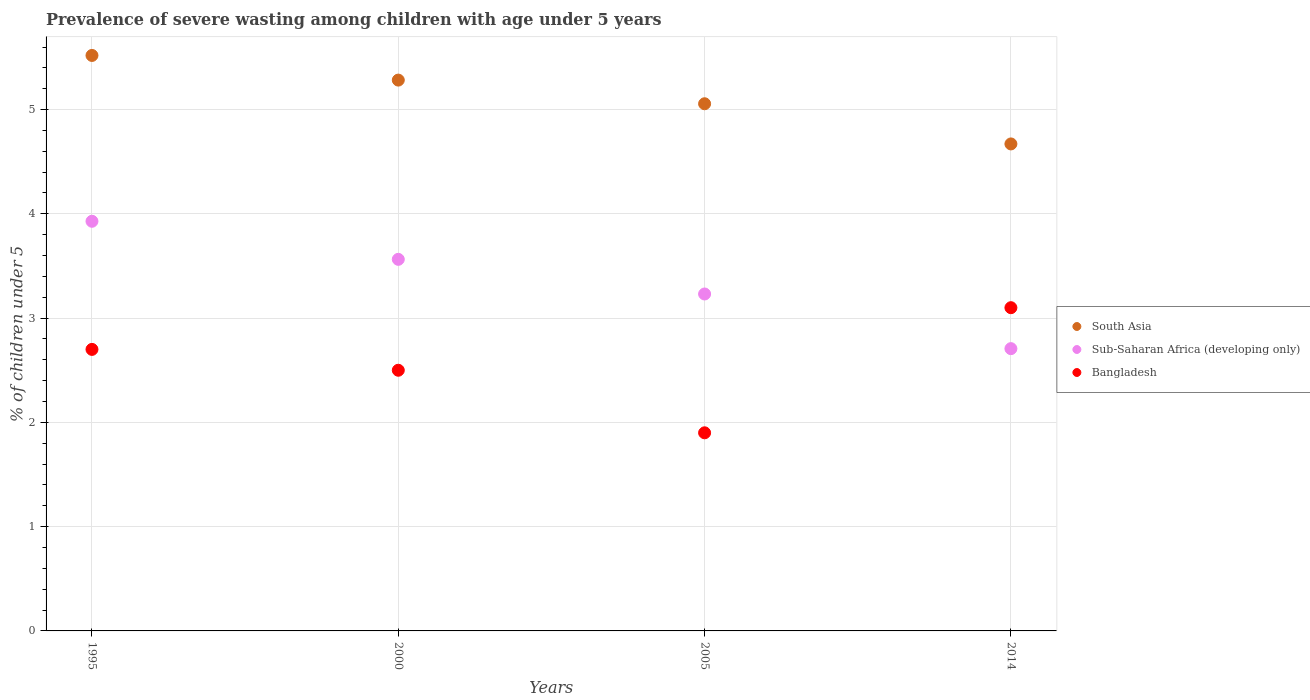Is the number of dotlines equal to the number of legend labels?
Provide a short and direct response. Yes. Across all years, what is the maximum percentage of severely wasted children in South Asia?
Provide a succinct answer. 5.52. Across all years, what is the minimum percentage of severely wasted children in Bangladesh?
Make the answer very short. 1.9. In which year was the percentage of severely wasted children in Sub-Saharan Africa (developing only) maximum?
Ensure brevity in your answer.  1995. In which year was the percentage of severely wasted children in South Asia minimum?
Give a very brief answer. 2014. What is the total percentage of severely wasted children in Sub-Saharan Africa (developing only) in the graph?
Ensure brevity in your answer.  13.43. What is the difference between the percentage of severely wasted children in Bangladesh in 2005 and that in 2014?
Ensure brevity in your answer.  -1.2. What is the difference between the percentage of severely wasted children in South Asia in 2014 and the percentage of severely wasted children in Sub-Saharan Africa (developing only) in 2000?
Give a very brief answer. 1.11. What is the average percentage of severely wasted children in Bangladesh per year?
Your response must be concise. 2.55. In the year 2000, what is the difference between the percentage of severely wasted children in Bangladesh and percentage of severely wasted children in Sub-Saharan Africa (developing only)?
Ensure brevity in your answer.  -1.06. What is the ratio of the percentage of severely wasted children in South Asia in 2000 to that in 2005?
Keep it short and to the point. 1.04. Is the percentage of severely wasted children in Sub-Saharan Africa (developing only) in 2000 less than that in 2014?
Your response must be concise. No. Is the difference between the percentage of severely wasted children in Bangladesh in 1995 and 2005 greater than the difference between the percentage of severely wasted children in Sub-Saharan Africa (developing only) in 1995 and 2005?
Offer a terse response. Yes. What is the difference between the highest and the second highest percentage of severely wasted children in South Asia?
Give a very brief answer. 0.24. What is the difference between the highest and the lowest percentage of severely wasted children in Bangladesh?
Your response must be concise. 1.2. In how many years, is the percentage of severely wasted children in Bangladesh greater than the average percentage of severely wasted children in Bangladesh taken over all years?
Your answer should be compact. 2. Is the sum of the percentage of severely wasted children in Bangladesh in 1995 and 2005 greater than the maximum percentage of severely wasted children in Sub-Saharan Africa (developing only) across all years?
Offer a very short reply. Yes. Does the percentage of severely wasted children in Sub-Saharan Africa (developing only) monotonically increase over the years?
Ensure brevity in your answer.  No. Is the percentage of severely wasted children in Sub-Saharan Africa (developing only) strictly greater than the percentage of severely wasted children in Bangladesh over the years?
Keep it short and to the point. No. Is the percentage of severely wasted children in South Asia strictly less than the percentage of severely wasted children in Sub-Saharan Africa (developing only) over the years?
Your response must be concise. No. How many dotlines are there?
Give a very brief answer. 3. What is the difference between two consecutive major ticks on the Y-axis?
Provide a succinct answer. 1. Are the values on the major ticks of Y-axis written in scientific E-notation?
Keep it short and to the point. No. Does the graph contain any zero values?
Make the answer very short. No. Does the graph contain grids?
Offer a terse response. Yes. Where does the legend appear in the graph?
Your answer should be very brief. Center right. How are the legend labels stacked?
Provide a short and direct response. Vertical. What is the title of the graph?
Provide a short and direct response. Prevalence of severe wasting among children with age under 5 years. Does "Other small states" appear as one of the legend labels in the graph?
Your response must be concise. No. What is the label or title of the Y-axis?
Keep it short and to the point. % of children under 5. What is the % of children under 5 in South Asia in 1995?
Your answer should be very brief. 5.52. What is the % of children under 5 of Sub-Saharan Africa (developing only) in 1995?
Your response must be concise. 3.93. What is the % of children under 5 of Bangladesh in 1995?
Offer a very short reply. 2.7. What is the % of children under 5 in South Asia in 2000?
Offer a terse response. 5.28. What is the % of children under 5 of Sub-Saharan Africa (developing only) in 2000?
Make the answer very short. 3.56. What is the % of children under 5 in Bangladesh in 2000?
Your answer should be compact. 2.5. What is the % of children under 5 of South Asia in 2005?
Make the answer very short. 5.06. What is the % of children under 5 of Sub-Saharan Africa (developing only) in 2005?
Your response must be concise. 3.23. What is the % of children under 5 in Bangladesh in 2005?
Ensure brevity in your answer.  1.9. What is the % of children under 5 in South Asia in 2014?
Your answer should be very brief. 4.67. What is the % of children under 5 in Sub-Saharan Africa (developing only) in 2014?
Ensure brevity in your answer.  2.71. What is the % of children under 5 of Bangladesh in 2014?
Offer a very short reply. 3.1. Across all years, what is the maximum % of children under 5 of South Asia?
Keep it short and to the point. 5.52. Across all years, what is the maximum % of children under 5 of Sub-Saharan Africa (developing only)?
Make the answer very short. 3.93. Across all years, what is the maximum % of children under 5 in Bangladesh?
Keep it short and to the point. 3.1. Across all years, what is the minimum % of children under 5 of South Asia?
Give a very brief answer. 4.67. Across all years, what is the minimum % of children under 5 of Sub-Saharan Africa (developing only)?
Ensure brevity in your answer.  2.71. Across all years, what is the minimum % of children under 5 in Bangladesh?
Offer a terse response. 1.9. What is the total % of children under 5 of South Asia in the graph?
Your response must be concise. 20.53. What is the total % of children under 5 in Sub-Saharan Africa (developing only) in the graph?
Ensure brevity in your answer.  13.43. What is the difference between the % of children under 5 of South Asia in 1995 and that in 2000?
Offer a very short reply. 0.24. What is the difference between the % of children under 5 of Sub-Saharan Africa (developing only) in 1995 and that in 2000?
Give a very brief answer. 0.37. What is the difference between the % of children under 5 of Bangladesh in 1995 and that in 2000?
Provide a succinct answer. 0.2. What is the difference between the % of children under 5 in South Asia in 1995 and that in 2005?
Your answer should be compact. 0.46. What is the difference between the % of children under 5 in Sub-Saharan Africa (developing only) in 1995 and that in 2005?
Your answer should be very brief. 0.7. What is the difference between the % of children under 5 in Bangladesh in 1995 and that in 2005?
Your answer should be very brief. 0.8. What is the difference between the % of children under 5 of South Asia in 1995 and that in 2014?
Ensure brevity in your answer.  0.85. What is the difference between the % of children under 5 of Sub-Saharan Africa (developing only) in 1995 and that in 2014?
Your answer should be compact. 1.22. What is the difference between the % of children under 5 in South Asia in 2000 and that in 2005?
Your answer should be very brief. 0.23. What is the difference between the % of children under 5 of Sub-Saharan Africa (developing only) in 2000 and that in 2005?
Offer a very short reply. 0.33. What is the difference between the % of children under 5 in South Asia in 2000 and that in 2014?
Offer a terse response. 0.61. What is the difference between the % of children under 5 in Sub-Saharan Africa (developing only) in 2000 and that in 2014?
Ensure brevity in your answer.  0.86. What is the difference between the % of children under 5 in South Asia in 2005 and that in 2014?
Give a very brief answer. 0.39. What is the difference between the % of children under 5 of Sub-Saharan Africa (developing only) in 2005 and that in 2014?
Provide a short and direct response. 0.52. What is the difference between the % of children under 5 of South Asia in 1995 and the % of children under 5 of Sub-Saharan Africa (developing only) in 2000?
Make the answer very short. 1.96. What is the difference between the % of children under 5 of South Asia in 1995 and the % of children under 5 of Bangladesh in 2000?
Your answer should be compact. 3.02. What is the difference between the % of children under 5 of Sub-Saharan Africa (developing only) in 1995 and the % of children under 5 of Bangladesh in 2000?
Your response must be concise. 1.43. What is the difference between the % of children under 5 in South Asia in 1995 and the % of children under 5 in Sub-Saharan Africa (developing only) in 2005?
Give a very brief answer. 2.29. What is the difference between the % of children under 5 in South Asia in 1995 and the % of children under 5 in Bangladesh in 2005?
Offer a very short reply. 3.62. What is the difference between the % of children under 5 in Sub-Saharan Africa (developing only) in 1995 and the % of children under 5 in Bangladesh in 2005?
Your answer should be very brief. 2.03. What is the difference between the % of children under 5 of South Asia in 1995 and the % of children under 5 of Sub-Saharan Africa (developing only) in 2014?
Ensure brevity in your answer.  2.81. What is the difference between the % of children under 5 of South Asia in 1995 and the % of children under 5 of Bangladesh in 2014?
Your answer should be very brief. 2.42. What is the difference between the % of children under 5 of Sub-Saharan Africa (developing only) in 1995 and the % of children under 5 of Bangladesh in 2014?
Your answer should be compact. 0.83. What is the difference between the % of children under 5 in South Asia in 2000 and the % of children under 5 in Sub-Saharan Africa (developing only) in 2005?
Make the answer very short. 2.05. What is the difference between the % of children under 5 in South Asia in 2000 and the % of children under 5 in Bangladesh in 2005?
Ensure brevity in your answer.  3.38. What is the difference between the % of children under 5 of Sub-Saharan Africa (developing only) in 2000 and the % of children under 5 of Bangladesh in 2005?
Offer a terse response. 1.66. What is the difference between the % of children under 5 of South Asia in 2000 and the % of children under 5 of Sub-Saharan Africa (developing only) in 2014?
Your answer should be very brief. 2.58. What is the difference between the % of children under 5 of South Asia in 2000 and the % of children under 5 of Bangladesh in 2014?
Your answer should be very brief. 2.18. What is the difference between the % of children under 5 of Sub-Saharan Africa (developing only) in 2000 and the % of children under 5 of Bangladesh in 2014?
Provide a succinct answer. 0.46. What is the difference between the % of children under 5 in South Asia in 2005 and the % of children under 5 in Sub-Saharan Africa (developing only) in 2014?
Provide a succinct answer. 2.35. What is the difference between the % of children under 5 of South Asia in 2005 and the % of children under 5 of Bangladesh in 2014?
Offer a very short reply. 1.96. What is the difference between the % of children under 5 of Sub-Saharan Africa (developing only) in 2005 and the % of children under 5 of Bangladesh in 2014?
Your response must be concise. 0.13. What is the average % of children under 5 in South Asia per year?
Your answer should be compact. 5.13. What is the average % of children under 5 of Sub-Saharan Africa (developing only) per year?
Provide a short and direct response. 3.36. What is the average % of children under 5 of Bangladesh per year?
Your response must be concise. 2.55. In the year 1995, what is the difference between the % of children under 5 in South Asia and % of children under 5 in Sub-Saharan Africa (developing only)?
Offer a very short reply. 1.59. In the year 1995, what is the difference between the % of children under 5 in South Asia and % of children under 5 in Bangladesh?
Your answer should be very brief. 2.82. In the year 1995, what is the difference between the % of children under 5 of Sub-Saharan Africa (developing only) and % of children under 5 of Bangladesh?
Offer a terse response. 1.23. In the year 2000, what is the difference between the % of children under 5 in South Asia and % of children under 5 in Sub-Saharan Africa (developing only)?
Offer a very short reply. 1.72. In the year 2000, what is the difference between the % of children under 5 in South Asia and % of children under 5 in Bangladesh?
Offer a terse response. 2.78. In the year 2000, what is the difference between the % of children under 5 in Sub-Saharan Africa (developing only) and % of children under 5 in Bangladesh?
Your answer should be compact. 1.06. In the year 2005, what is the difference between the % of children under 5 in South Asia and % of children under 5 in Sub-Saharan Africa (developing only)?
Make the answer very short. 1.82. In the year 2005, what is the difference between the % of children under 5 in South Asia and % of children under 5 in Bangladesh?
Ensure brevity in your answer.  3.16. In the year 2005, what is the difference between the % of children under 5 of Sub-Saharan Africa (developing only) and % of children under 5 of Bangladesh?
Make the answer very short. 1.33. In the year 2014, what is the difference between the % of children under 5 in South Asia and % of children under 5 in Sub-Saharan Africa (developing only)?
Your response must be concise. 1.96. In the year 2014, what is the difference between the % of children under 5 of South Asia and % of children under 5 of Bangladesh?
Make the answer very short. 1.57. In the year 2014, what is the difference between the % of children under 5 of Sub-Saharan Africa (developing only) and % of children under 5 of Bangladesh?
Your answer should be very brief. -0.39. What is the ratio of the % of children under 5 in South Asia in 1995 to that in 2000?
Offer a very short reply. 1.04. What is the ratio of the % of children under 5 in Sub-Saharan Africa (developing only) in 1995 to that in 2000?
Make the answer very short. 1.1. What is the ratio of the % of children under 5 of South Asia in 1995 to that in 2005?
Offer a terse response. 1.09. What is the ratio of the % of children under 5 in Sub-Saharan Africa (developing only) in 1995 to that in 2005?
Make the answer very short. 1.22. What is the ratio of the % of children under 5 in Bangladesh in 1995 to that in 2005?
Keep it short and to the point. 1.42. What is the ratio of the % of children under 5 of South Asia in 1995 to that in 2014?
Your answer should be compact. 1.18. What is the ratio of the % of children under 5 of Sub-Saharan Africa (developing only) in 1995 to that in 2014?
Ensure brevity in your answer.  1.45. What is the ratio of the % of children under 5 of Bangladesh in 1995 to that in 2014?
Ensure brevity in your answer.  0.87. What is the ratio of the % of children under 5 in South Asia in 2000 to that in 2005?
Keep it short and to the point. 1.04. What is the ratio of the % of children under 5 in Sub-Saharan Africa (developing only) in 2000 to that in 2005?
Offer a very short reply. 1.1. What is the ratio of the % of children under 5 of Bangladesh in 2000 to that in 2005?
Keep it short and to the point. 1.32. What is the ratio of the % of children under 5 in South Asia in 2000 to that in 2014?
Your answer should be very brief. 1.13. What is the ratio of the % of children under 5 of Sub-Saharan Africa (developing only) in 2000 to that in 2014?
Provide a succinct answer. 1.32. What is the ratio of the % of children under 5 in Bangladesh in 2000 to that in 2014?
Give a very brief answer. 0.81. What is the ratio of the % of children under 5 in South Asia in 2005 to that in 2014?
Ensure brevity in your answer.  1.08. What is the ratio of the % of children under 5 of Sub-Saharan Africa (developing only) in 2005 to that in 2014?
Provide a succinct answer. 1.19. What is the ratio of the % of children under 5 of Bangladesh in 2005 to that in 2014?
Your answer should be very brief. 0.61. What is the difference between the highest and the second highest % of children under 5 in South Asia?
Make the answer very short. 0.24. What is the difference between the highest and the second highest % of children under 5 of Sub-Saharan Africa (developing only)?
Ensure brevity in your answer.  0.37. What is the difference between the highest and the lowest % of children under 5 in South Asia?
Provide a short and direct response. 0.85. What is the difference between the highest and the lowest % of children under 5 in Sub-Saharan Africa (developing only)?
Your answer should be very brief. 1.22. 